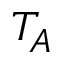Convert formula to latex. <formula><loc_0><loc_0><loc_500><loc_500>T _ { A }</formula> 